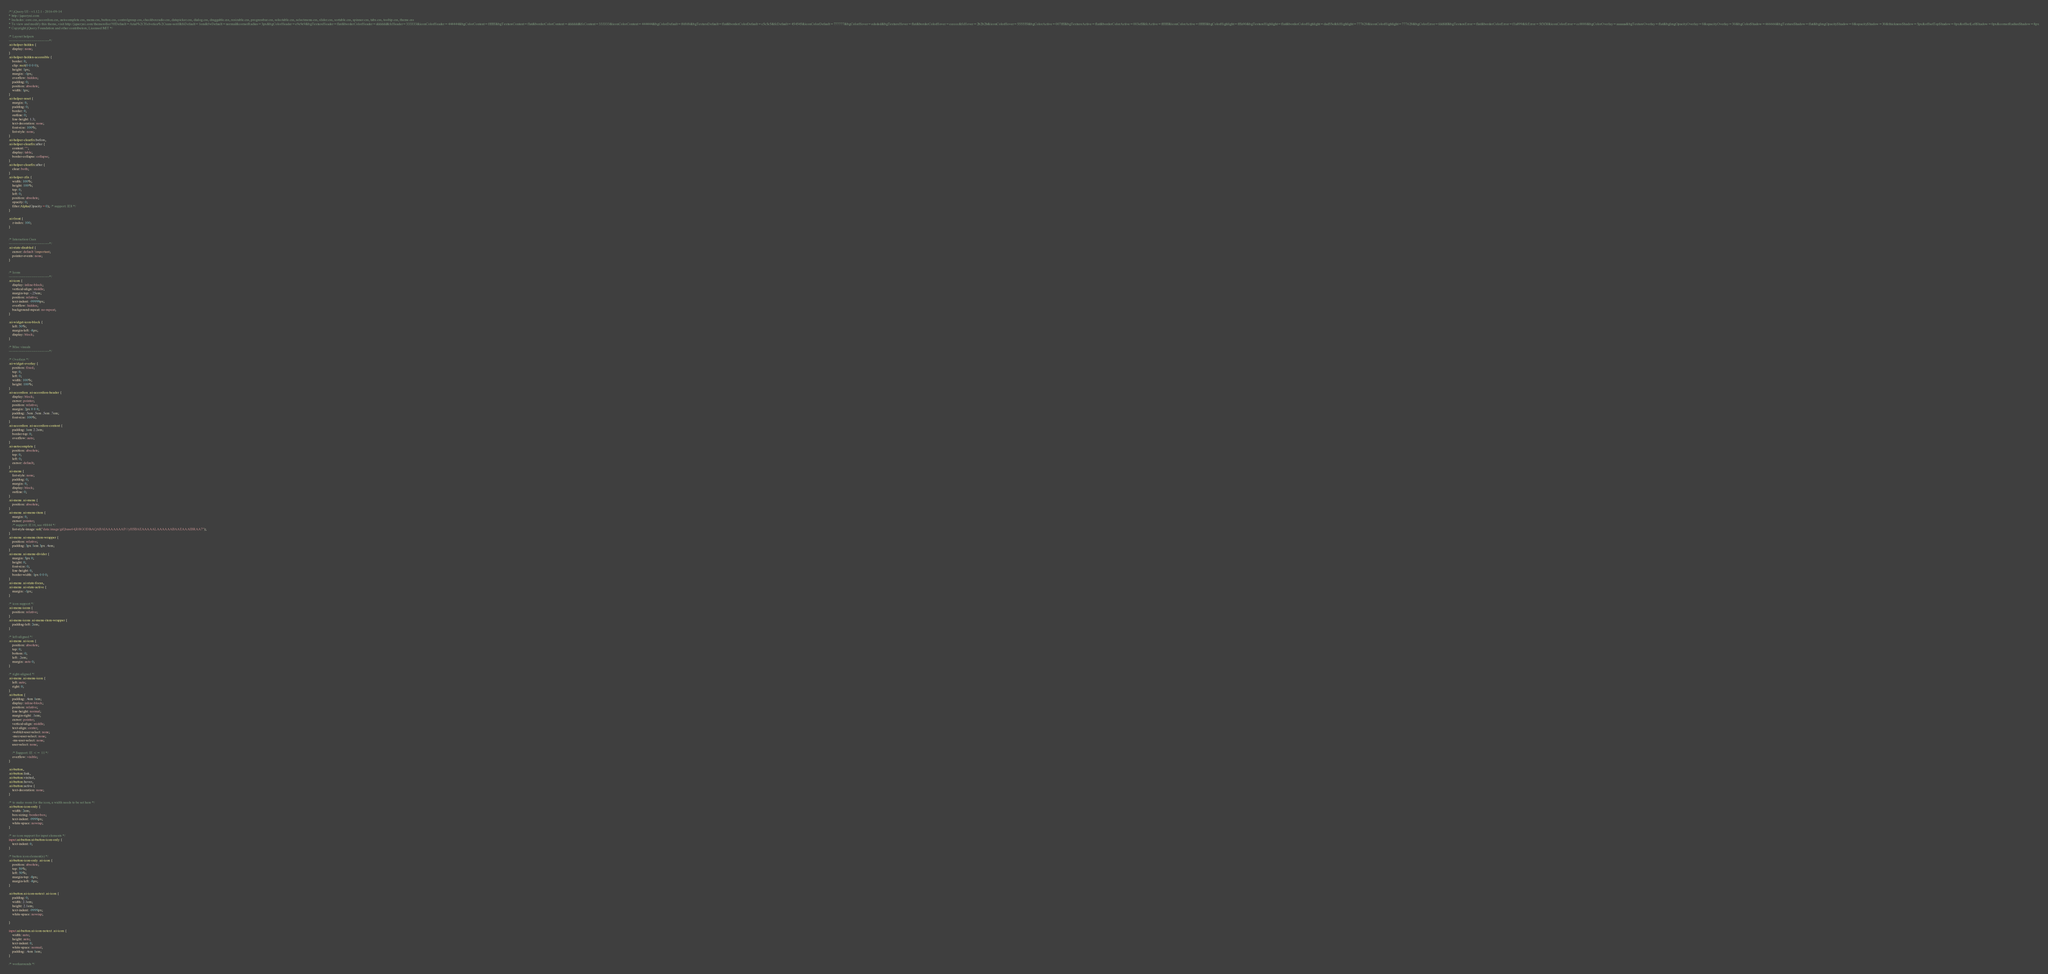Convert code to text. <code><loc_0><loc_0><loc_500><loc_500><_CSS_>/*! jQuery UI - v1.12.1 - 2016-09-14
* http://jqueryui.com
* Includes: core.css, accordion.css, autocomplete.css, menu.css, button.css, controlgroup.css, checkboxradio.css, datepicker.css, dialog.css, draggable.css, resizable.css, progressbar.css, selectable.css, selectmenu.css, slider.css, sortable.css, spinner.css, tabs.css, tooltip.css, theme.css
* To view and modify this theme, visit http://jqueryui.com/themeroller/?ffDefault=Arial%2CHelvetica%2Csans-serif&fsDefault=1em&fwDefault=normal&cornerRadius=3px&bgColorHeader=e9e9e9&bgTextureHeader=flat&borderColorHeader=dddddd&fcHeader=333333&iconColorHeader=444444&bgColorContent=ffffff&bgTextureContent=flat&borderColorContent=dddddd&fcContent=333333&iconColorContent=444444&bgColorDefault=f6f6f6&bgTextureDefault=flat&borderColorDefault=c5c5c5&fcDefault=454545&iconColorDefault=777777&bgColorHover=ededed&bgTextureHover=flat&borderColorHover=cccccc&fcHover=2b2b2b&iconColorHover=555555&bgColorActive=007fff&bgTextureActive=flat&borderColorActive=003eff&fcActive=ffffff&iconColorActive=ffffff&bgColorHighlight=fffa90&bgTextureHighlight=flat&borderColorHighlight=dad55e&fcHighlight=777620&iconColorHighlight=777620&bgColorError=fddfdf&bgTextureError=flat&borderColorError=f1a899&fcError=5f3f3f&iconColorError=cc0000&bgColorOverlay=aaaaaa&bgTextureOverlay=flat&bgImgOpacityOverlay=0&opacityOverlay=30&bgColorShadow=666666&bgTextureShadow=flat&bgImgOpacityShadow=0&opacityShadow=30&thicknessShadow=5px&offsetTopShadow=0px&offsetLeftShadow=0px&cornerRadiusShadow=8px
* Copyright jQuery Foundation and other contributors; Licensed MIT */

/* Layout helpers
----------------------------------*/
.ui-helper-hidden {
	display: none;
}
.ui-helper-hidden-accessible {
	border: 0;
	clip: rect(0 0 0 0);
	height: 1px;
	margin: -1px;
	overflow: hidden;
	padding: 0;
	position: absolute;
	width: 1px;
}
.ui-helper-reset {
	margin: 0;
	padding: 0;
	border: 0;
	outline: 0;
	line-height: 1.3;
	text-decoration: none;
	font-size: 100%;
	list-style: none;
}
.ui-helper-clearfix:before,
.ui-helper-clearfix:after {
	content: "";
	display: table;
	border-collapse: collapse;
}
.ui-helper-clearfix:after {
	clear: both;
}
.ui-helper-zfix {
	width: 100%;
	height: 100%;
	top: 0;
	left: 0;
	position: absolute;
	opacity: 0;
	filter:Alpha(Opacity=0); /* support: IE8 */
}

.ui-front {
	z-index: 100;
}


/* Interaction Cues
----------------------------------*/
.ui-state-disabled {
	cursor: default !important;
	pointer-events: none;
}


/* Icons
----------------------------------*/
.ui-icon {
	display: inline-block;
	vertical-align: middle;
	margin-top: -.25em;
	position: relative;
	text-indent: -99999px;
	overflow: hidden;
	background-repeat: no-repeat;
}

.ui-widget-icon-block {
	left: 50%;
	margin-left: -8px;
	display: block;
}

/* Misc visuals
----------------------------------*/

/* Overlays */
.ui-widget-overlay {
	position: fixed;
	top: 0;
	left: 0;
	width: 100%;
	height: 100%;
}
.ui-accordion .ui-accordion-header {
	display: block;
	cursor: pointer;
	position: relative;
	margin: 2px 0 0 0;
	padding: .5em .5em .5em .7em;
	font-size: 100%;
}
.ui-accordion .ui-accordion-content {
	padding: 1em 2.2em;
	border-top: 0;
	overflow: auto;
}
.ui-autocomplete {
	position: absolute;
	top: 0;
	left: 0;
	cursor: default;
}
.ui-menu {
	list-style: none;
	padding: 0;
	margin: 0;
	display: block;
	outline: 0;
}
.ui-menu .ui-menu {
	position: absolute;
}
.ui-menu .ui-menu-item {
	margin: 0;
	cursor: pointer;
	/* support: IE10, see #8844 */
	list-style-image: url("data:image/gif;base64,R0lGODlhAQABAIAAAAAAAP///yH5BAEAAAAALAAAAAABAAEAAAIBRAA7");
}
.ui-menu .ui-menu-item-wrapper {
	position: relative;
	padding: 3px 1em 3px .4em;
}
.ui-menu .ui-menu-divider {
	margin: 5px 0;
	height: 0;
	font-size: 0;
	line-height: 0;
	border-width: 1px 0 0 0;
}
.ui-menu .ui-state-focus,
.ui-menu .ui-state-active {
	margin: -1px;
}

/* icon support */
.ui-menu-icons {
	position: relative;
}
.ui-menu-icons .ui-menu-item-wrapper {
	padding-left: 2em;
}

/* left-aligned */
.ui-menu .ui-icon {
	position: absolute;
	top: 0;
	bottom: 0;
	left: .2em;
	margin: auto 0;
}

/* right-aligned */
.ui-menu .ui-menu-icon {
	left: auto;
	right: 0;
}
.ui-button {
	padding: .4em 1em;
	display: inline-block;
	position: relative;
	line-height: normal;
	margin-right: .1em;
	cursor: pointer;
	vertical-align: middle;
	text-align: center;
	-webkit-user-select: none;
	-moz-user-select: none;
	-ms-user-select: none;
	user-select: none;

	/* Support: IE <= 11 */
	overflow: visible;
}

.ui-button,
.ui-button:link,
.ui-button:visited,
.ui-button:hover,
.ui-button:active {
	text-decoration: none;
}

/* to make room for the icon, a width needs to be set here */
.ui-button-icon-only {
	width: 2em;
	box-sizing: border-box;
	text-indent: -9999px;
	white-space: nowrap;
}

/* no icon support for input elements */
input.ui-button.ui-button-icon-only {
	text-indent: 0;
}

/* button icon element(s) */
.ui-button-icon-only .ui-icon {
	position: absolute;
	top: 50%;
	left: 50%;
	margin-top: -8px;
	margin-left: -8px;
}

.ui-button.ui-icon-notext .ui-icon {
	padding: 0;
	width: 2.1em;
	height: 2.1em;
	text-indent: -9999px;
	white-space: nowrap;

}

input.ui-button.ui-icon-notext .ui-icon {
	width: auto;
	height: auto;
	text-indent: 0;
	white-space: normal;
	padding: .4em 1em;
}

/* workarounds */</code> 